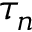<formula> <loc_0><loc_0><loc_500><loc_500>\tau _ { n }</formula> 